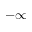<formula> <loc_0><loc_0><loc_500><loc_500>- \infty</formula> 